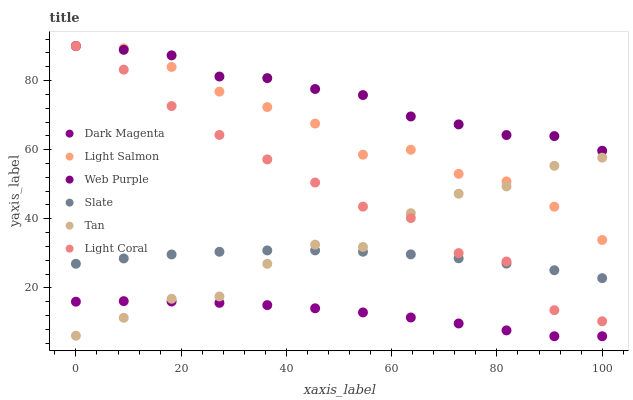Does Dark Magenta have the minimum area under the curve?
Answer yes or no. Yes. Does Web Purple have the maximum area under the curve?
Answer yes or no. Yes. Does Slate have the minimum area under the curve?
Answer yes or no. No. Does Slate have the maximum area under the curve?
Answer yes or no. No. Is Slate the smoothest?
Answer yes or no. Yes. Is Tan the roughest?
Answer yes or no. Yes. Is Dark Magenta the smoothest?
Answer yes or no. No. Is Dark Magenta the roughest?
Answer yes or no. No. Does Dark Magenta have the lowest value?
Answer yes or no. Yes. Does Slate have the lowest value?
Answer yes or no. No. Does Web Purple have the highest value?
Answer yes or no. Yes. Does Slate have the highest value?
Answer yes or no. No. Is Dark Magenta less than Slate?
Answer yes or no. Yes. Is Light Salmon greater than Dark Magenta?
Answer yes or no. Yes. Does Web Purple intersect Light Salmon?
Answer yes or no. Yes. Is Web Purple less than Light Salmon?
Answer yes or no. No. Is Web Purple greater than Light Salmon?
Answer yes or no. No. Does Dark Magenta intersect Slate?
Answer yes or no. No. 